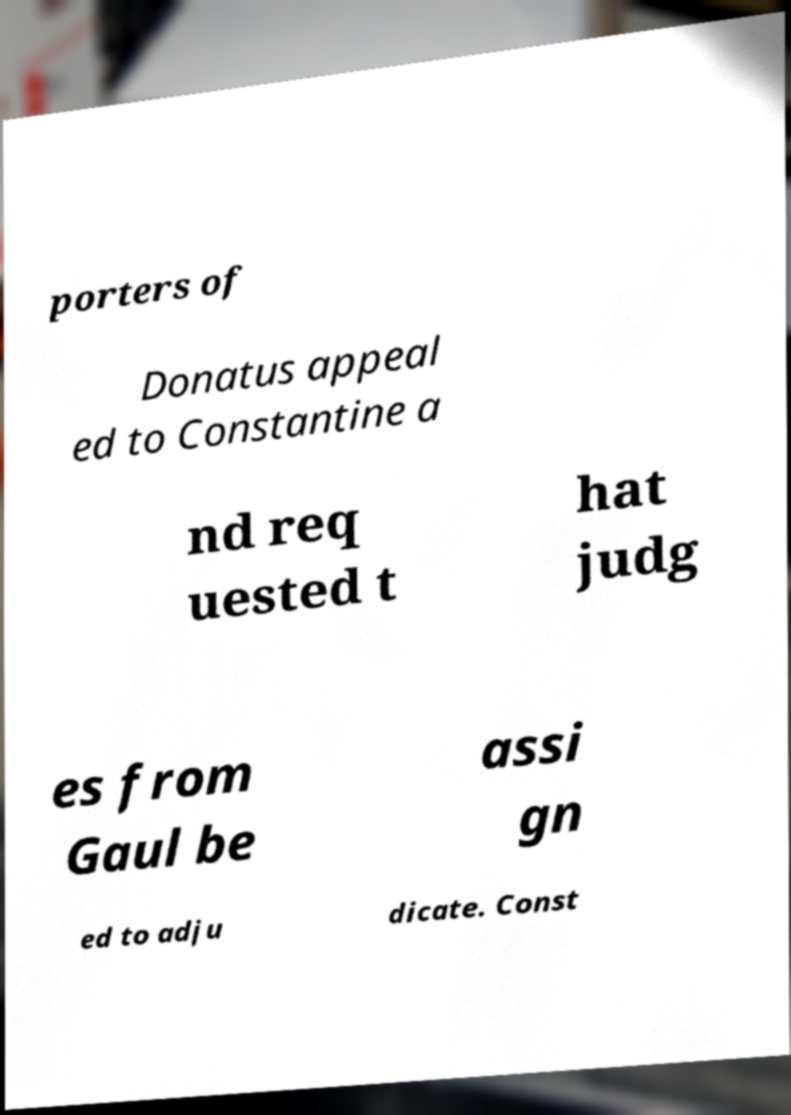Can you read and provide the text displayed in the image?This photo seems to have some interesting text. Can you extract and type it out for me? porters of Donatus appeal ed to Constantine a nd req uested t hat judg es from Gaul be assi gn ed to adju dicate. Const 